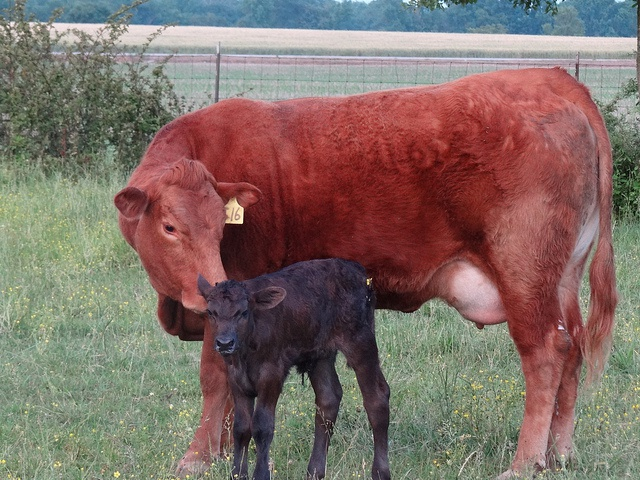Describe the objects in this image and their specific colors. I can see cow in teal, brown, maroon, and black tones and cow in teal, black, and gray tones in this image. 